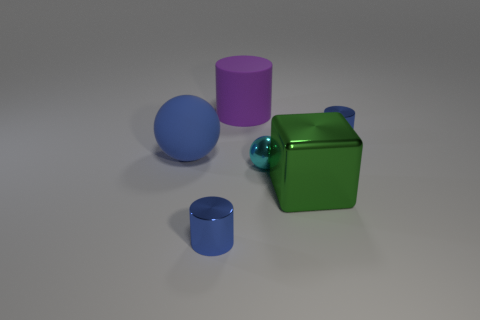Are there more green things that are to the right of the big purple cylinder than tiny blue cylinders that are in front of the cyan ball?
Your response must be concise. No. Is the material of the tiny cylinder in front of the big green shiny thing the same as the cylinder that is to the right of the matte cylinder?
Make the answer very short. Yes. The purple thing that is the same size as the cube is what shape?
Ensure brevity in your answer.  Cylinder. Are there any tiny yellow rubber things of the same shape as the green thing?
Offer a very short reply. No. Do the shiny object left of the tiny cyan sphere and the metal cylinder behind the big green block have the same color?
Provide a succinct answer. Yes. Are there any small cyan spheres to the right of the cyan ball?
Offer a very short reply. No. What material is the tiny thing that is behind the green shiny object and on the left side of the big cube?
Give a very brief answer. Metal. Are the cylinder that is in front of the green cube and the large purple cylinder made of the same material?
Your response must be concise. No. What material is the large purple thing?
Offer a very short reply. Rubber. How big is the blue shiny cylinder on the right side of the purple cylinder?
Provide a short and direct response. Small. 